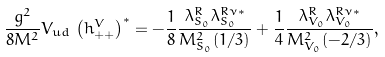<formula> <loc_0><loc_0><loc_500><loc_500>\frac { g ^ { 2 } } { 8 M ^ { 2 } } V _ { u d } \, \left ( h ^ { V } _ { + + } \right ) ^ { * } = - \frac { 1 } { 8 } \frac { \lambda ^ { R } _ { S _ { 0 } } \lambda ^ { R \nu * } _ { S _ { 0 } } } { M ^ { 2 } _ { S _ { 0 } } ( 1 / 3 ) } + \frac { 1 } { 4 } \frac { \lambda ^ { R } _ { V _ { 0 } } \lambda ^ { R \nu * } _ { V _ { 0 } } } { M ^ { 2 } _ { V _ { 0 } } ( - 2 / 3 ) } ,</formula> 